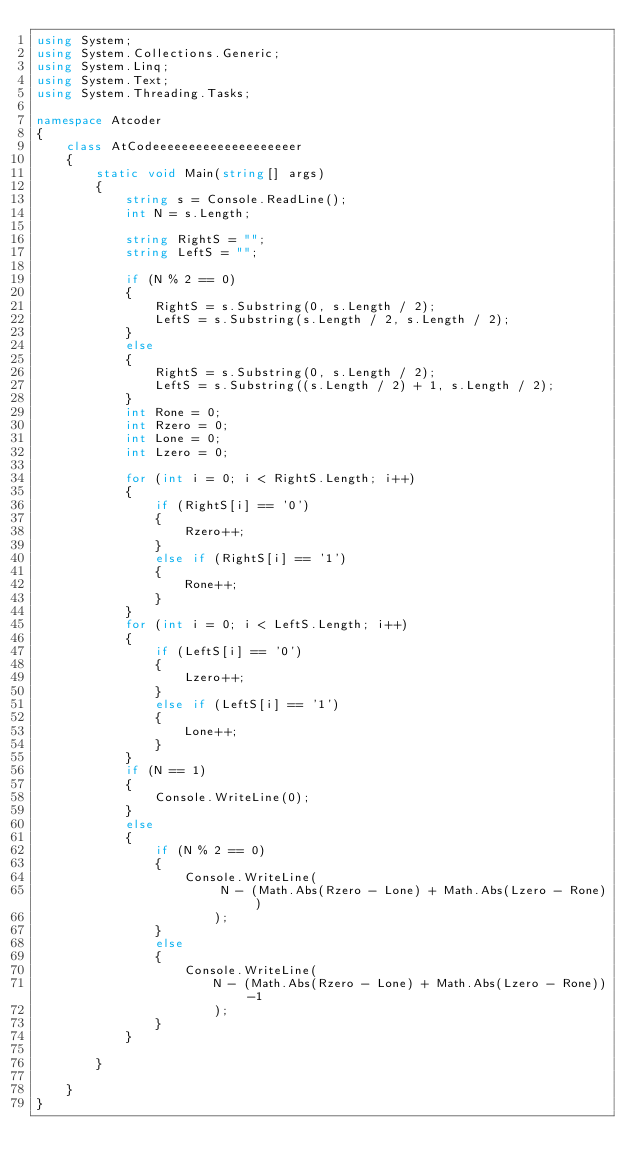<code> <loc_0><loc_0><loc_500><loc_500><_C#_>using System;
using System.Collections.Generic;
using System.Linq;
using System.Text;
using System.Threading.Tasks;

namespace Atcoder
{
    class AtCodeeeeeeeeeeeeeeeeeeeer
    {
        static void Main(string[] args)
        {
            string s = Console.ReadLine();
            int N = s.Length;

            string RightS = "";
            string LeftS = "";

            if (N % 2 == 0)
            {
                RightS = s.Substring(0, s.Length / 2);
                LeftS = s.Substring(s.Length / 2, s.Length / 2);
            }
            else
            {
                RightS = s.Substring(0, s.Length / 2);
                LeftS = s.Substring((s.Length / 2) + 1, s.Length / 2);
            }
            int Rone = 0;
            int Rzero = 0;
            int Lone = 0;
            int Lzero = 0;

            for (int i = 0; i < RightS.Length; i++)
            {
                if (RightS[i] == '0')
                {
                    Rzero++;
                }
                else if (RightS[i] == '1')
                {
                    Rone++;
                }
            }
            for (int i = 0; i < LeftS.Length; i++)
            {
                if (LeftS[i] == '0')
                {
                    Lzero++;
                }
                else if (LeftS[i] == '1')
                {
                    Lone++;
                }
            }
            if (N == 1)
            {
                Console.WriteLine(0);
            }
            else
            {
                if (N % 2 == 0)
                {
                    Console.WriteLine(
                         N - (Math.Abs(Rzero - Lone) + Math.Abs(Lzero - Rone))
                        );
                }
                else
                {
                    Console.WriteLine(
                        N - (Math.Abs(Rzero - Lone) + Math.Abs(Lzero - Rone))-1
                        );
                }
            }

        }

    }
}
</code> 